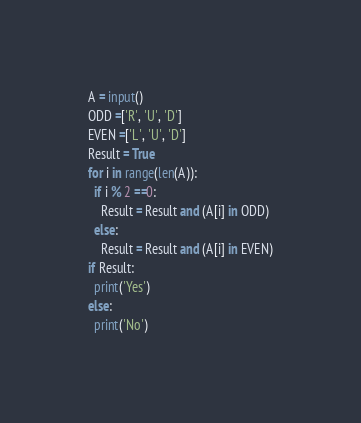<code> <loc_0><loc_0><loc_500><loc_500><_Python_>A = input()
ODD =['R', 'U', 'D']
EVEN =['L', 'U', 'D']
Result = True
for i in range(len(A)):
  if i % 2 ==0:
    Result = Result and (A[i] in ODD)
  else:
    Result = Result and (A[i] in EVEN)
if Result:
  print('Yes')
else:
  print('No')</code> 